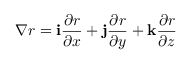Convert formula to latex. <formula><loc_0><loc_0><loc_500><loc_500>\nabla r = { i \frac { \partial r } { \partial x } + j \frac { \partial r } { \partial y } + k \frac { \partial r } { \partial z } }</formula> 